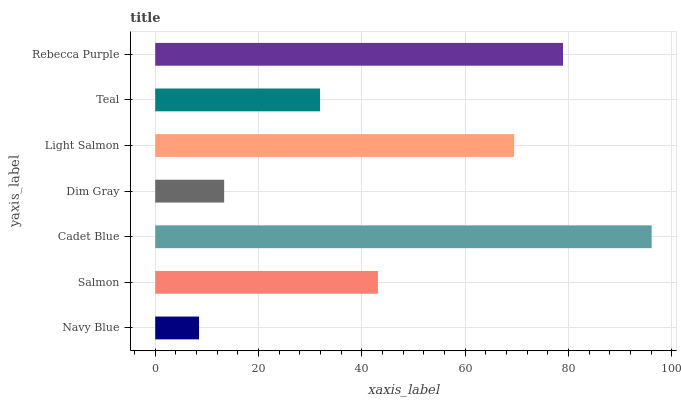Is Navy Blue the minimum?
Answer yes or no. Yes. Is Cadet Blue the maximum?
Answer yes or no. Yes. Is Salmon the minimum?
Answer yes or no. No. Is Salmon the maximum?
Answer yes or no. No. Is Salmon greater than Navy Blue?
Answer yes or no. Yes. Is Navy Blue less than Salmon?
Answer yes or no. Yes. Is Navy Blue greater than Salmon?
Answer yes or no. No. Is Salmon less than Navy Blue?
Answer yes or no. No. Is Salmon the high median?
Answer yes or no. Yes. Is Salmon the low median?
Answer yes or no. Yes. Is Dim Gray the high median?
Answer yes or no. No. Is Navy Blue the low median?
Answer yes or no. No. 